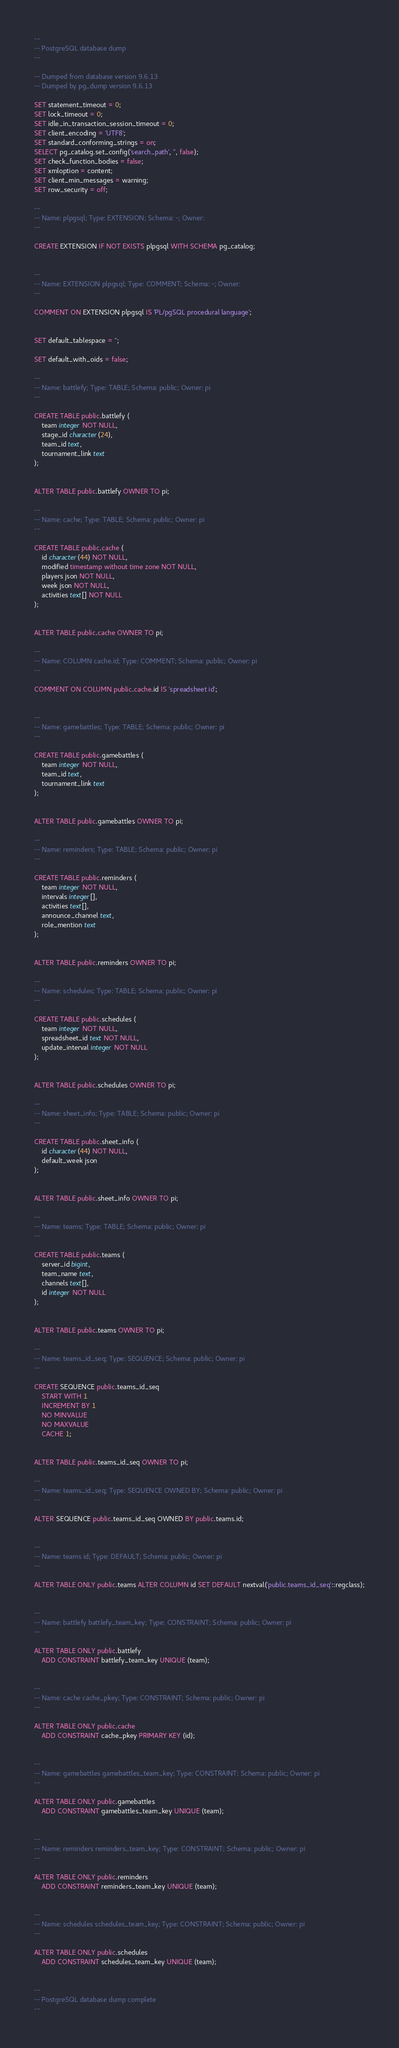<code> <loc_0><loc_0><loc_500><loc_500><_SQL_>--
-- PostgreSQL database dump
--

-- Dumped from database version 9.6.13
-- Dumped by pg_dump version 9.6.13

SET statement_timeout = 0;
SET lock_timeout = 0;
SET idle_in_transaction_session_timeout = 0;
SET client_encoding = 'UTF8';
SET standard_conforming_strings = on;
SELECT pg_catalog.set_config('search_path', '', false);
SET check_function_bodies = false;
SET xmloption = content;
SET client_min_messages = warning;
SET row_security = off;

--
-- Name: plpgsql; Type: EXTENSION; Schema: -; Owner: 
--

CREATE EXTENSION IF NOT EXISTS plpgsql WITH SCHEMA pg_catalog;


--
-- Name: EXTENSION plpgsql; Type: COMMENT; Schema: -; Owner: 
--

COMMENT ON EXTENSION plpgsql IS 'PL/pgSQL procedural language';


SET default_tablespace = '';

SET default_with_oids = false;

--
-- Name: battlefy; Type: TABLE; Schema: public; Owner: pi
--

CREATE TABLE public.battlefy (
    team integer NOT NULL,
    stage_id character(24),
    team_id text,
    tournament_link text
);


ALTER TABLE public.battlefy OWNER TO pi;

--
-- Name: cache; Type: TABLE; Schema: public; Owner: pi
--

CREATE TABLE public.cache (
    id character(44) NOT NULL,
    modified timestamp without time zone NOT NULL,
    players json NOT NULL,
    week json NOT NULL,
    activities text[] NOT NULL
);


ALTER TABLE public.cache OWNER TO pi;

--
-- Name: COLUMN cache.id; Type: COMMENT; Schema: public; Owner: pi
--

COMMENT ON COLUMN public.cache.id IS 'spreadsheet id';


--
-- Name: gamebattles; Type: TABLE; Schema: public; Owner: pi
--

CREATE TABLE public.gamebattles (
    team integer NOT NULL,
    team_id text,
    tournament_link text
);


ALTER TABLE public.gamebattles OWNER TO pi;

--
-- Name: reminders; Type: TABLE; Schema: public; Owner: pi
--

CREATE TABLE public.reminders (
    team integer NOT NULL,
    intervals integer[],
    activities text[],
    announce_channel text,
    role_mention text
);


ALTER TABLE public.reminders OWNER TO pi;

--
-- Name: schedules; Type: TABLE; Schema: public; Owner: pi
--

CREATE TABLE public.schedules (
    team integer NOT NULL,
    spreadsheet_id text NOT NULL,
    update_interval integer NOT NULL
);


ALTER TABLE public.schedules OWNER TO pi;

--
-- Name: sheet_info; Type: TABLE; Schema: public; Owner: pi
--

CREATE TABLE public.sheet_info (
    id character(44) NOT NULL,
    default_week json
);


ALTER TABLE public.sheet_info OWNER TO pi;

--
-- Name: teams; Type: TABLE; Schema: public; Owner: pi
--

CREATE TABLE public.teams (
    server_id bigint,
    team_name text,
    channels text[],
    id integer NOT NULL
);


ALTER TABLE public.teams OWNER TO pi;

--
-- Name: teams_id_seq; Type: SEQUENCE; Schema: public; Owner: pi
--

CREATE SEQUENCE public.teams_id_seq
    START WITH 1
    INCREMENT BY 1
    NO MINVALUE
    NO MAXVALUE
    CACHE 1;


ALTER TABLE public.teams_id_seq OWNER TO pi;

--
-- Name: teams_id_seq; Type: SEQUENCE OWNED BY; Schema: public; Owner: pi
--

ALTER SEQUENCE public.teams_id_seq OWNED BY public.teams.id;


--
-- Name: teams id; Type: DEFAULT; Schema: public; Owner: pi
--

ALTER TABLE ONLY public.teams ALTER COLUMN id SET DEFAULT nextval('public.teams_id_seq'::regclass);


--
-- Name: battlefy battlefy_team_key; Type: CONSTRAINT; Schema: public; Owner: pi
--

ALTER TABLE ONLY public.battlefy
    ADD CONSTRAINT battlefy_team_key UNIQUE (team);


--
-- Name: cache cache_pkey; Type: CONSTRAINT; Schema: public; Owner: pi
--

ALTER TABLE ONLY public.cache
    ADD CONSTRAINT cache_pkey PRIMARY KEY (id);


--
-- Name: gamebattles gamebattles_team_key; Type: CONSTRAINT; Schema: public; Owner: pi
--

ALTER TABLE ONLY public.gamebattles
    ADD CONSTRAINT gamebattles_team_key UNIQUE (team);


--
-- Name: reminders reminders_team_key; Type: CONSTRAINT; Schema: public; Owner: pi
--

ALTER TABLE ONLY public.reminders
    ADD CONSTRAINT reminders_team_key UNIQUE (team);


--
-- Name: schedules schedules_team_key; Type: CONSTRAINT; Schema: public; Owner: pi
--

ALTER TABLE ONLY public.schedules
    ADD CONSTRAINT schedules_team_key UNIQUE (team);


--
-- PostgreSQL database dump complete
--

</code> 